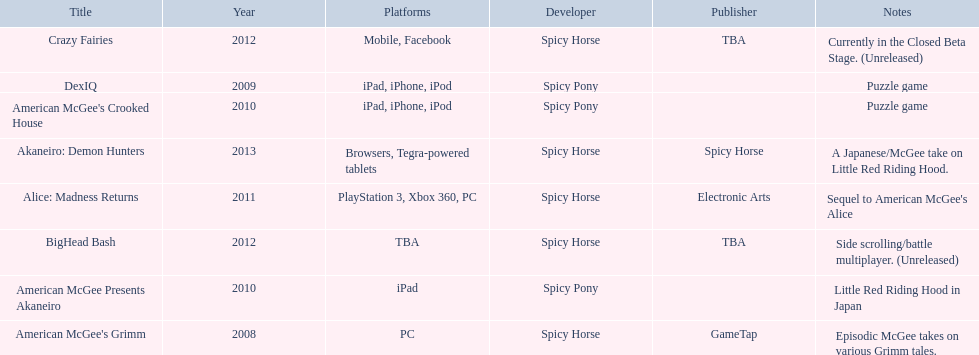What are all the titles? American McGee's Grimm, DexIQ, American McGee Presents Akaneiro, American McGee's Crooked House, Alice: Madness Returns, BigHead Bash, Crazy Fairies, Akaneiro: Demon Hunters. What platforms were they available on? PC, iPad, iPhone, iPod, iPad, iPad, iPhone, iPod, PlayStation 3, Xbox 360, PC, TBA, Mobile, Facebook, Browsers, Tegra-powered tablets. And which were available only on the ipad? American McGee Presents Akaneiro. 